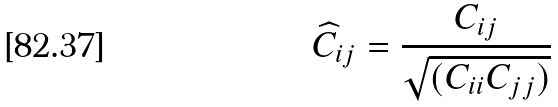Convert formula to latex. <formula><loc_0><loc_0><loc_500><loc_500>\widehat { C } _ { i j } = \frac { C _ { i j } } { \sqrt { ( C _ { i i } C _ { j j } ) } }</formula> 